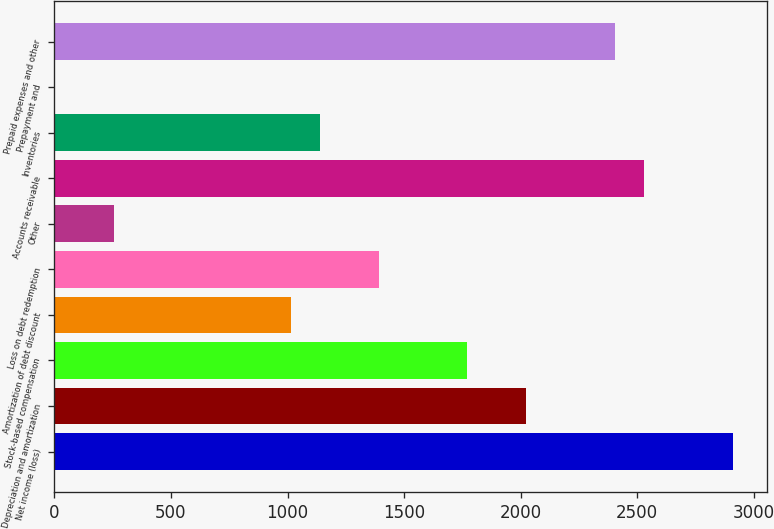Convert chart to OTSL. <chart><loc_0><loc_0><loc_500><loc_500><bar_chart><fcel>Net income (loss)<fcel>Depreciation and amortization<fcel>Stock-based compensation<fcel>Amortization of debt discount<fcel>Loss on debt redemption<fcel>Other<fcel>Accounts receivable<fcel>Inventories<fcel>Prepayment and<fcel>Prepaid expenses and other<nl><fcel>2910.5<fcel>2025<fcel>1772<fcel>1013<fcel>1392.5<fcel>254<fcel>2531<fcel>1139.5<fcel>1<fcel>2404.5<nl></chart> 